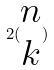Convert formula to latex. <formula><loc_0><loc_0><loc_500><loc_500>2 ( \begin{matrix} n \\ k \end{matrix} )</formula> 